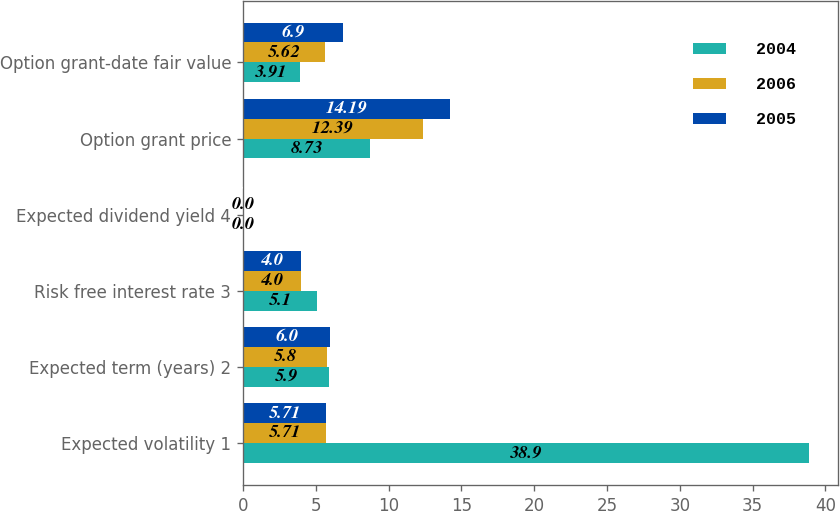<chart> <loc_0><loc_0><loc_500><loc_500><stacked_bar_chart><ecel><fcel>Expected volatility 1<fcel>Expected term (years) 2<fcel>Risk free interest rate 3<fcel>Expected dividend yield 4<fcel>Option grant price<fcel>Option grant-date fair value<nl><fcel>2004<fcel>38.9<fcel>5.9<fcel>5.1<fcel>0<fcel>8.73<fcel>3.91<nl><fcel>2006<fcel>5.71<fcel>5.8<fcel>4<fcel>0<fcel>12.39<fcel>5.62<nl><fcel>2005<fcel>5.71<fcel>6<fcel>4<fcel>0<fcel>14.19<fcel>6.9<nl></chart> 